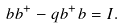Convert formula to latex. <formula><loc_0><loc_0><loc_500><loc_500>b b ^ { + } - q b ^ { + } b = I .</formula> 